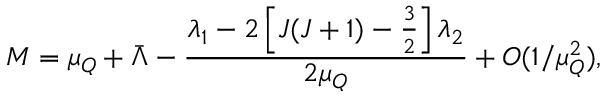Convert formula to latex. <formula><loc_0><loc_0><loc_500><loc_500>M = \mu _ { Q } + \bar { \Lambda } - \frac { \lambda _ { 1 } - 2 \left [ J ( J + 1 ) - \frac { 3 } { 2 } \right ] \lambda _ { 2 } } { 2 \mu _ { Q } } + O ( 1 / \mu _ { Q } ^ { 2 } ) ,</formula> 